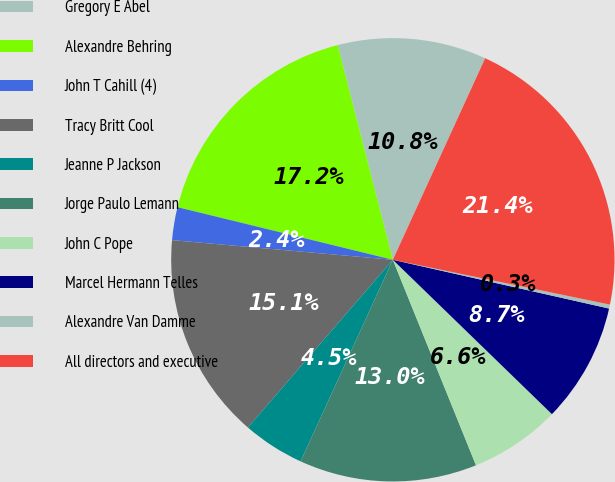<chart> <loc_0><loc_0><loc_500><loc_500><pie_chart><fcel>Gregory E Abel<fcel>Alexandre Behring<fcel>John T Cahill (4)<fcel>Tracy Britt Cool<fcel>Jeanne P Jackson<fcel>Jorge Paulo Lemann<fcel>John C Pope<fcel>Marcel Hermann Telles<fcel>Alexandre Van Damme<fcel>All directors and executive<nl><fcel>10.84%<fcel>17.18%<fcel>2.4%<fcel>15.07%<fcel>4.51%<fcel>12.95%<fcel>6.62%<fcel>8.73%<fcel>0.29%<fcel>21.4%<nl></chart> 